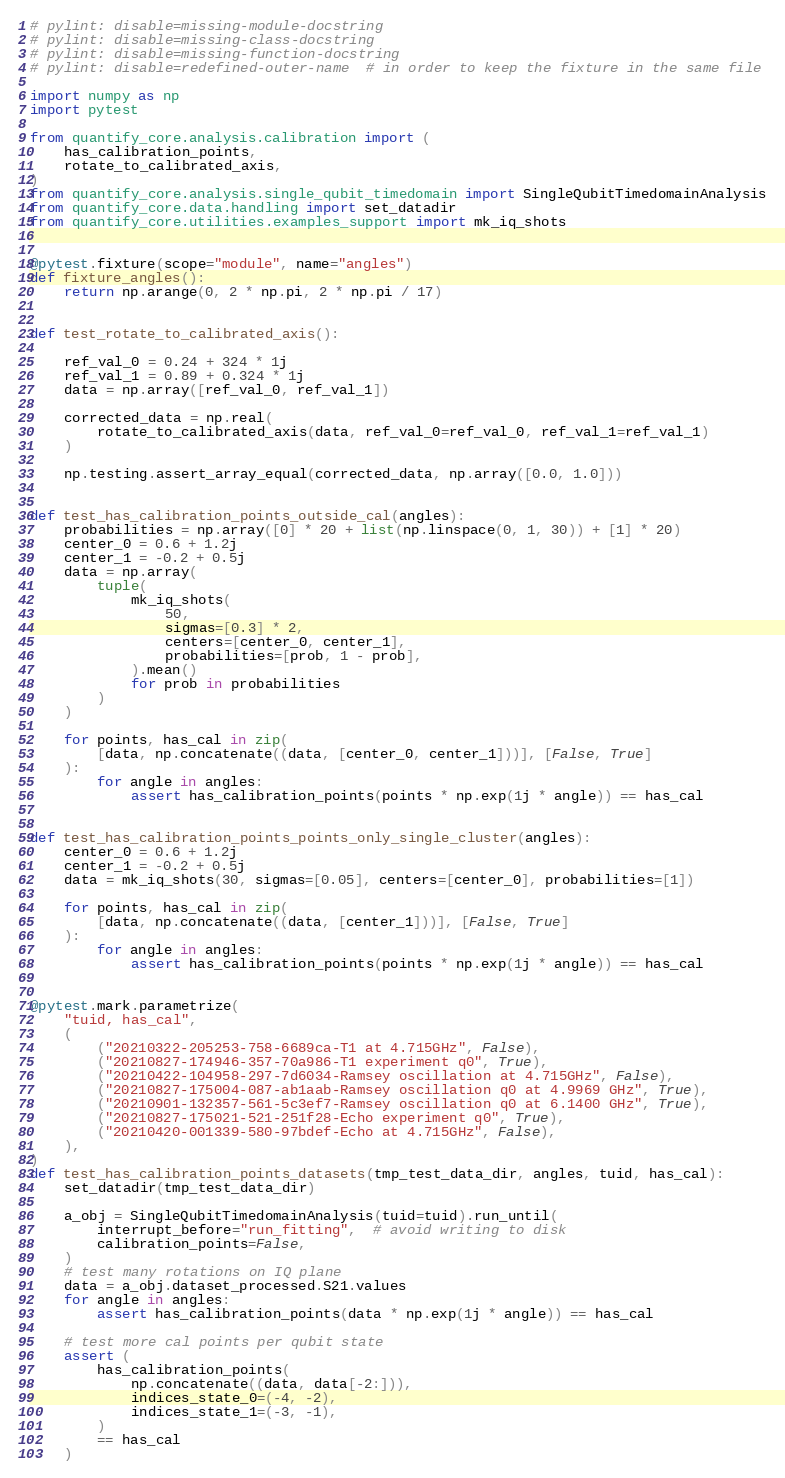Convert code to text. <code><loc_0><loc_0><loc_500><loc_500><_Python_># pylint: disable=missing-module-docstring
# pylint: disable=missing-class-docstring
# pylint: disable=missing-function-docstring
# pylint: disable=redefined-outer-name  # in order to keep the fixture in the same file

import numpy as np
import pytest

from quantify_core.analysis.calibration import (
    has_calibration_points,
    rotate_to_calibrated_axis,
)
from quantify_core.analysis.single_qubit_timedomain import SingleQubitTimedomainAnalysis
from quantify_core.data.handling import set_datadir
from quantify_core.utilities.examples_support import mk_iq_shots


@pytest.fixture(scope="module", name="angles")
def fixture_angles():
    return np.arange(0, 2 * np.pi, 2 * np.pi / 17)


def test_rotate_to_calibrated_axis():

    ref_val_0 = 0.24 + 324 * 1j
    ref_val_1 = 0.89 + 0.324 * 1j
    data = np.array([ref_val_0, ref_val_1])

    corrected_data = np.real(
        rotate_to_calibrated_axis(data, ref_val_0=ref_val_0, ref_val_1=ref_val_1)
    )

    np.testing.assert_array_equal(corrected_data, np.array([0.0, 1.0]))


def test_has_calibration_points_outside_cal(angles):
    probabilities = np.array([0] * 20 + list(np.linspace(0, 1, 30)) + [1] * 20)
    center_0 = 0.6 + 1.2j
    center_1 = -0.2 + 0.5j
    data = np.array(
        tuple(
            mk_iq_shots(
                50,
                sigmas=[0.3] * 2,
                centers=[center_0, center_1],
                probabilities=[prob, 1 - prob],
            ).mean()
            for prob in probabilities
        )
    )

    for points, has_cal in zip(
        [data, np.concatenate((data, [center_0, center_1]))], [False, True]
    ):
        for angle in angles:
            assert has_calibration_points(points * np.exp(1j * angle)) == has_cal


def test_has_calibration_points_points_only_single_cluster(angles):
    center_0 = 0.6 + 1.2j
    center_1 = -0.2 + 0.5j
    data = mk_iq_shots(30, sigmas=[0.05], centers=[center_0], probabilities=[1])

    for points, has_cal in zip(
        [data, np.concatenate((data, [center_1]))], [False, True]
    ):
        for angle in angles:
            assert has_calibration_points(points * np.exp(1j * angle)) == has_cal


@pytest.mark.parametrize(
    "tuid, has_cal",
    (
        ("20210322-205253-758-6689ca-T1 at 4.715GHz", False),
        ("20210827-174946-357-70a986-T1 experiment q0", True),
        ("20210422-104958-297-7d6034-Ramsey oscillation at 4.715GHz", False),
        ("20210827-175004-087-ab1aab-Ramsey oscillation q0 at 4.9969 GHz", True),
        ("20210901-132357-561-5c3ef7-Ramsey oscillation q0 at 6.1400 GHz", True),
        ("20210827-175021-521-251f28-Echo experiment q0", True),
        ("20210420-001339-580-97bdef-Echo at 4.715GHz", False),
    ),
)
def test_has_calibration_points_datasets(tmp_test_data_dir, angles, tuid, has_cal):
    set_datadir(tmp_test_data_dir)

    a_obj = SingleQubitTimedomainAnalysis(tuid=tuid).run_until(
        interrupt_before="run_fitting",  # avoid writing to disk
        calibration_points=False,
    )
    # test many rotations on IQ plane
    data = a_obj.dataset_processed.S21.values
    for angle in angles:
        assert has_calibration_points(data * np.exp(1j * angle)) == has_cal

    # test more cal points per qubit state
    assert (
        has_calibration_points(
            np.concatenate((data, data[-2:])),
            indices_state_0=(-4, -2),
            indices_state_1=(-3, -1),
        )
        == has_cal
    )
</code> 